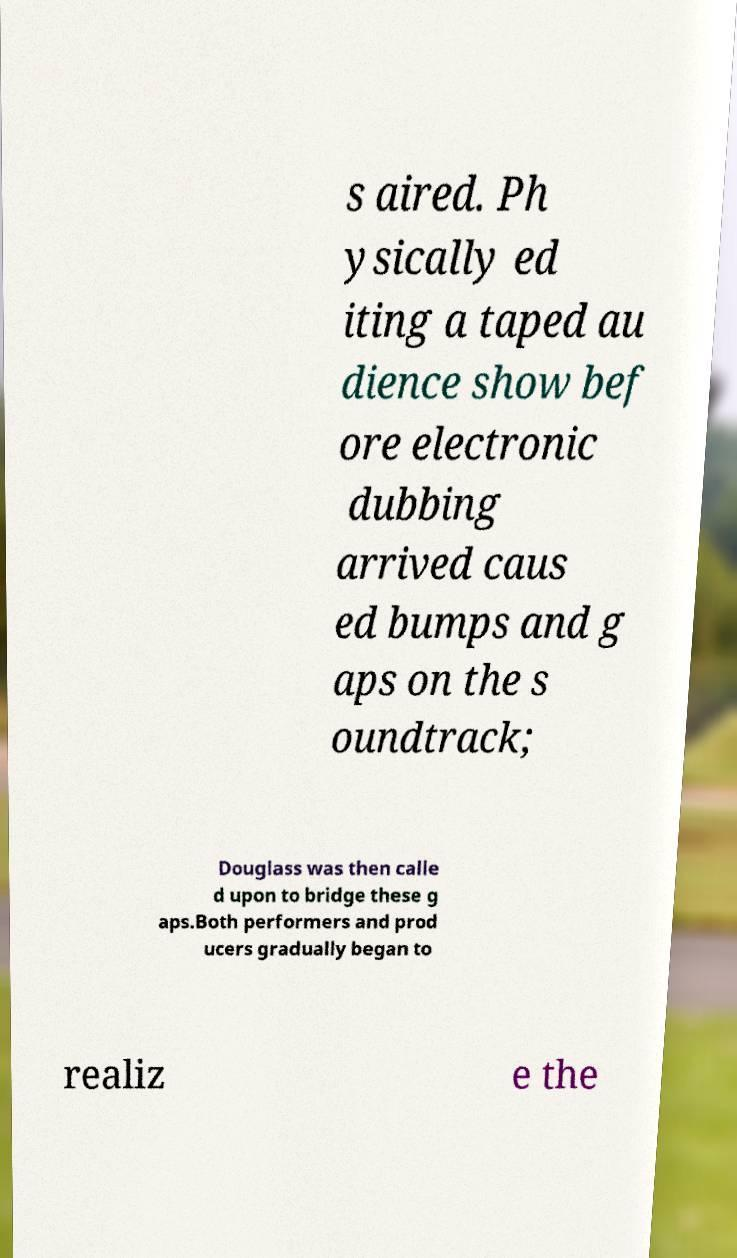Please read and relay the text visible in this image. What does it say? s aired. Ph ysically ed iting a taped au dience show bef ore electronic dubbing arrived caus ed bumps and g aps on the s oundtrack; Douglass was then calle d upon to bridge these g aps.Both performers and prod ucers gradually began to realiz e the 